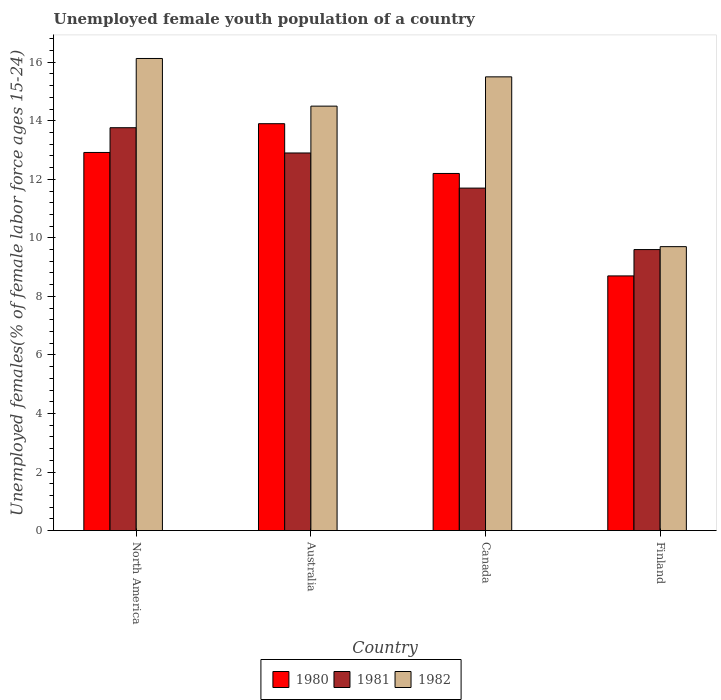How many groups of bars are there?
Offer a very short reply. 4. How many bars are there on the 1st tick from the right?
Provide a short and direct response. 3. In how many cases, is the number of bars for a given country not equal to the number of legend labels?
Provide a succinct answer. 0. What is the percentage of unemployed female youth population in 1982 in Finland?
Ensure brevity in your answer.  9.7. Across all countries, what is the maximum percentage of unemployed female youth population in 1981?
Keep it short and to the point. 13.76. Across all countries, what is the minimum percentage of unemployed female youth population in 1981?
Make the answer very short. 9.6. In which country was the percentage of unemployed female youth population in 1982 maximum?
Make the answer very short. North America. In which country was the percentage of unemployed female youth population in 1980 minimum?
Keep it short and to the point. Finland. What is the total percentage of unemployed female youth population in 1982 in the graph?
Give a very brief answer. 55.83. What is the difference between the percentage of unemployed female youth population in 1981 in Finland and that in North America?
Offer a terse response. -4.16. What is the difference between the percentage of unemployed female youth population in 1981 in Finland and the percentage of unemployed female youth population in 1982 in Australia?
Your answer should be compact. -4.9. What is the average percentage of unemployed female youth population in 1982 per country?
Give a very brief answer. 13.96. What is the difference between the percentage of unemployed female youth population of/in 1980 and percentage of unemployed female youth population of/in 1981 in Finland?
Keep it short and to the point. -0.9. What is the ratio of the percentage of unemployed female youth population in 1981 in Australia to that in Canada?
Provide a succinct answer. 1.1. What is the difference between the highest and the second highest percentage of unemployed female youth population in 1982?
Offer a terse response. 1.63. What is the difference between the highest and the lowest percentage of unemployed female youth population in 1980?
Give a very brief answer. 5.2. What does the 1st bar from the left in North America represents?
Your answer should be very brief. 1980. What does the 1st bar from the right in Finland represents?
Keep it short and to the point. 1982. How many countries are there in the graph?
Provide a short and direct response. 4. What is the difference between two consecutive major ticks on the Y-axis?
Provide a succinct answer. 2. Are the values on the major ticks of Y-axis written in scientific E-notation?
Make the answer very short. No. Does the graph contain any zero values?
Give a very brief answer. No. Does the graph contain grids?
Make the answer very short. No. How many legend labels are there?
Make the answer very short. 3. What is the title of the graph?
Your response must be concise. Unemployed female youth population of a country. Does "1996" appear as one of the legend labels in the graph?
Make the answer very short. No. What is the label or title of the Y-axis?
Ensure brevity in your answer.  Unemployed females(% of female labor force ages 15-24). What is the Unemployed females(% of female labor force ages 15-24) in 1980 in North America?
Provide a succinct answer. 12.92. What is the Unemployed females(% of female labor force ages 15-24) in 1981 in North America?
Your response must be concise. 13.76. What is the Unemployed females(% of female labor force ages 15-24) in 1982 in North America?
Offer a very short reply. 16.13. What is the Unemployed females(% of female labor force ages 15-24) of 1980 in Australia?
Offer a very short reply. 13.9. What is the Unemployed females(% of female labor force ages 15-24) in 1981 in Australia?
Your answer should be compact. 12.9. What is the Unemployed females(% of female labor force ages 15-24) in 1980 in Canada?
Keep it short and to the point. 12.2. What is the Unemployed females(% of female labor force ages 15-24) of 1981 in Canada?
Ensure brevity in your answer.  11.7. What is the Unemployed females(% of female labor force ages 15-24) of 1982 in Canada?
Offer a very short reply. 15.5. What is the Unemployed females(% of female labor force ages 15-24) in 1980 in Finland?
Give a very brief answer. 8.7. What is the Unemployed females(% of female labor force ages 15-24) in 1981 in Finland?
Provide a succinct answer. 9.6. What is the Unemployed females(% of female labor force ages 15-24) in 1982 in Finland?
Keep it short and to the point. 9.7. Across all countries, what is the maximum Unemployed females(% of female labor force ages 15-24) in 1980?
Give a very brief answer. 13.9. Across all countries, what is the maximum Unemployed females(% of female labor force ages 15-24) of 1981?
Keep it short and to the point. 13.76. Across all countries, what is the maximum Unemployed females(% of female labor force ages 15-24) of 1982?
Provide a succinct answer. 16.13. Across all countries, what is the minimum Unemployed females(% of female labor force ages 15-24) of 1980?
Your response must be concise. 8.7. Across all countries, what is the minimum Unemployed females(% of female labor force ages 15-24) in 1981?
Your answer should be compact. 9.6. Across all countries, what is the minimum Unemployed females(% of female labor force ages 15-24) in 1982?
Provide a succinct answer. 9.7. What is the total Unemployed females(% of female labor force ages 15-24) in 1980 in the graph?
Your answer should be very brief. 47.72. What is the total Unemployed females(% of female labor force ages 15-24) in 1981 in the graph?
Provide a short and direct response. 47.96. What is the total Unemployed females(% of female labor force ages 15-24) in 1982 in the graph?
Keep it short and to the point. 55.83. What is the difference between the Unemployed females(% of female labor force ages 15-24) of 1980 in North America and that in Australia?
Provide a short and direct response. -0.98. What is the difference between the Unemployed females(% of female labor force ages 15-24) of 1981 in North America and that in Australia?
Offer a terse response. 0.86. What is the difference between the Unemployed females(% of female labor force ages 15-24) of 1982 in North America and that in Australia?
Provide a short and direct response. 1.63. What is the difference between the Unemployed females(% of female labor force ages 15-24) of 1980 in North America and that in Canada?
Offer a very short reply. 0.72. What is the difference between the Unemployed females(% of female labor force ages 15-24) in 1981 in North America and that in Canada?
Provide a succinct answer. 2.06. What is the difference between the Unemployed females(% of female labor force ages 15-24) in 1982 in North America and that in Canada?
Provide a succinct answer. 0.63. What is the difference between the Unemployed females(% of female labor force ages 15-24) of 1980 in North America and that in Finland?
Provide a short and direct response. 4.22. What is the difference between the Unemployed females(% of female labor force ages 15-24) in 1981 in North America and that in Finland?
Provide a succinct answer. 4.16. What is the difference between the Unemployed females(% of female labor force ages 15-24) in 1982 in North America and that in Finland?
Your answer should be very brief. 6.43. What is the difference between the Unemployed females(% of female labor force ages 15-24) of 1980 in Australia and that in Canada?
Offer a terse response. 1.7. What is the difference between the Unemployed females(% of female labor force ages 15-24) of 1981 in Australia and that in Canada?
Keep it short and to the point. 1.2. What is the difference between the Unemployed females(% of female labor force ages 15-24) of 1982 in Australia and that in Canada?
Offer a terse response. -1. What is the difference between the Unemployed females(% of female labor force ages 15-24) in 1981 in Australia and that in Finland?
Give a very brief answer. 3.3. What is the difference between the Unemployed females(% of female labor force ages 15-24) in 1982 in Canada and that in Finland?
Ensure brevity in your answer.  5.8. What is the difference between the Unemployed females(% of female labor force ages 15-24) in 1980 in North America and the Unemployed females(% of female labor force ages 15-24) in 1981 in Australia?
Keep it short and to the point. 0.02. What is the difference between the Unemployed females(% of female labor force ages 15-24) in 1980 in North America and the Unemployed females(% of female labor force ages 15-24) in 1982 in Australia?
Offer a terse response. -1.58. What is the difference between the Unemployed females(% of female labor force ages 15-24) of 1981 in North America and the Unemployed females(% of female labor force ages 15-24) of 1982 in Australia?
Your answer should be very brief. -0.74. What is the difference between the Unemployed females(% of female labor force ages 15-24) in 1980 in North America and the Unemployed females(% of female labor force ages 15-24) in 1981 in Canada?
Ensure brevity in your answer.  1.22. What is the difference between the Unemployed females(% of female labor force ages 15-24) in 1980 in North America and the Unemployed females(% of female labor force ages 15-24) in 1982 in Canada?
Give a very brief answer. -2.58. What is the difference between the Unemployed females(% of female labor force ages 15-24) in 1981 in North America and the Unemployed females(% of female labor force ages 15-24) in 1982 in Canada?
Your answer should be very brief. -1.74. What is the difference between the Unemployed females(% of female labor force ages 15-24) of 1980 in North America and the Unemployed females(% of female labor force ages 15-24) of 1981 in Finland?
Offer a very short reply. 3.32. What is the difference between the Unemployed females(% of female labor force ages 15-24) of 1980 in North America and the Unemployed females(% of female labor force ages 15-24) of 1982 in Finland?
Give a very brief answer. 3.22. What is the difference between the Unemployed females(% of female labor force ages 15-24) in 1981 in North America and the Unemployed females(% of female labor force ages 15-24) in 1982 in Finland?
Provide a succinct answer. 4.06. What is the difference between the Unemployed females(% of female labor force ages 15-24) of 1980 in Australia and the Unemployed females(% of female labor force ages 15-24) of 1981 in Canada?
Make the answer very short. 2.2. What is the difference between the Unemployed females(% of female labor force ages 15-24) of 1980 in Australia and the Unemployed females(% of female labor force ages 15-24) of 1982 in Canada?
Give a very brief answer. -1.6. What is the difference between the Unemployed females(% of female labor force ages 15-24) of 1980 in Australia and the Unemployed females(% of female labor force ages 15-24) of 1981 in Finland?
Offer a terse response. 4.3. What is the difference between the Unemployed females(% of female labor force ages 15-24) of 1980 in Australia and the Unemployed females(% of female labor force ages 15-24) of 1982 in Finland?
Make the answer very short. 4.2. What is the difference between the Unemployed females(% of female labor force ages 15-24) in 1981 in Canada and the Unemployed females(% of female labor force ages 15-24) in 1982 in Finland?
Give a very brief answer. 2. What is the average Unemployed females(% of female labor force ages 15-24) of 1980 per country?
Ensure brevity in your answer.  11.93. What is the average Unemployed females(% of female labor force ages 15-24) of 1981 per country?
Your answer should be compact. 11.99. What is the average Unemployed females(% of female labor force ages 15-24) of 1982 per country?
Give a very brief answer. 13.96. What is the difference between the Unemployed females(% of female labor force ages 15-24) in 1980 and Unemployed females(% of female labor force ages 15-24) in 1981 in North America?
Offer a terse response. -0.85. What is the difference between the Unemployed females(% of female labor force ages 15-24) of 1980 and Unemployed females(% of female labor force ages 15-24) of 1982 in North America?
Offer a terse response. -3.21. What is the difference between the Unemployed females(% of female labor force ages 15-24) in 1981 and Unemployed females(% of female labor force ages 15-24) in 1982 in North America?
Provide a short and direct response. -2.37. What is the difference between the Unemployed females(% of female labor force ages 15-24) of 1980 and Unemployed females(% of female labor force ages 15-24) of 1981 in Australia?
Offer a very short reply. 1. What is the difference between the Unemployed females(% of female labor force ages 15-24) of 1980 and Unemployed females(% of female labor force ages 15-24) of 1982 in Australia?
Your answer should be compact. -0.6. What is the difference between the Unemployed females(% of female labor force ages 15-24) in 1980 and Unemployed females(% of female labor force ages 15-24) in 1981 in Canada?
Your answer should be very brief. 0.5. What is the difference between the Unemployed females(% of female labor force ages 15-24) of 1980 and Unemployed females(% of female labor force ages 15-24) of 1982 in Canada?
Keep it short and to the point. -3.3. What is the difference between the Unemployed females(% of female labor force ages 15-24) in 1981 and Unemployed females(% of female labor force ages 15-24) in 1982 in Canada?
Provide a succinct answer. -3.8. What is the difference between the Unemployed females(% of female labor force ages 15-24) in 1980 and Unemployed females(% of female labor force ages 15-24) in 1981 in Finland?
Your answer should be compact. -0.9. What is the ratio of the Unemployed females(% of female labor force ages 15-24) of 1980 in North America to that in Australia?
Your answer should be compact. 0.93. What is the ratio of the Unemployed females(% of female labor force ages 15-24) in 1981 in North America to that in Australia?
Give a very brief answer. 1.07. What is the ratio of the Unemployed females(% of female labor force ages 15-24) in 1982 in North America to that in Australia?
Ensure brevity in your answer.  1.11. What is the ratio of the Unemployed females(% of female labor force ages 15-24) in 1980 in North America to that in Canada?
Provide a short and direct response. 1.06. What is the ratio of the Unemployed females(% of female labor force ages 15-24) in 1981 in North America to that in Canada?
Your answer should be compact. 1.18. What is the ratio of the Unemployed females(% of female labor force ages 15-24) in 1982 in North America to that in Canada?
Provide a short and direct response. 1.04. What is the ratio of the Unemployed females(% of female labor force ages 15-24) of 1980 in North America to that in Finland?
Provide a succinct answer. 1.48. What is the ratio of the Unemployed females(% of female labor force ages 15-24) of 1981 in North America to that in Finland?
Provide a succinct answer. 1.43. What is the ratio of the Unemployed females(% of female labor force ages 15-24) of 1982 in North America to that in Finland?
Provide a short and direct response. 1.66. What is the ratio of the Unemployed females(% of female labor force ages 15-24) in 1980 in Australia to that in Canada?
Your answer should be very brief. 1.14. What is the ratio of the Unemployed females(% of female labor force ages 15-24) of 1981 in Australia to that in Canada?
Offer a terse response. 1.1. What is the ratio of the Unemployed females(% of female labor force ages 15-24) of 1982 in Australia to that in Canada?
Give a very brief answer. 0.94. What is the ratio of the Unemployed females(% of female labor force ages 15-24) in 1980 in Australia to that in Finland?
Provide a short and direct response. 1.6. What is the ratio of the Unemployed females(% of female labor force ages 15-24) of 1981 in Australia to that in Finland?
Ensure brevity in your answer.  1.34. What is the ratio of the Unemployed females(% of female labor force ages 15-24) of 1982 in Australia to that in Finland?
Provide a succinct answer. 1.49. What is the ratio of the Unemployed females(% of female labor force ages 15-24) of 1980 in Canada to that in Finland?
Offer a very short reply. 1.4. What is the ratio of the Unemployed females(% of female labor force ages 15-24) in 1981 in Canada to that in Finland?
Provide a succinct answer. 1.22. What is the ratio of the Unemployed females(% of female labor force ages 15-24) of 1982 in Canada to that in Finland?
Your response must be concise. 1.6. What is the difference between the highest and the second highest Unemployed females(% of female labor force ages 15-24) of 1980?
Give a very brief answer. 0.98. What is the difference between the highest and the second highest Unemployed females(% of female labor force ages 15-24) in 1981?
Your answer should be very brief. 0.86. What is the difference between the highest and the second highest Unemployed females(% of female labor force ages 15-24) in 1982?
Your answer should be compact. 0.63. What is the difference between the highest and the lowest Unemployed females(% of female labor force ages 15-24) of 1980?
Offer a very short reply. 5.2. What is the difference between the highest and the lowest Unemployed females(% of female labor force ages 15-24) in 1981?
Offer a very short reply. 4.16. What is the difference between the highest and the lowest Unemployed females(% of female labor force ages 15-24) of 1982?
Provide a succinct answer. 6.43. 